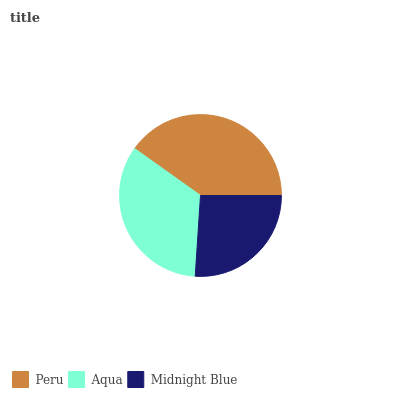Is Midnight Blue the minimum?
Answer yes or no. Yes. Is Peru the maximum?
Answer yes or no. Yes. Is Aqua the minimum?
Answer yes or no. No. Is Aqua the maximum?
Answer yes or no. No. Is Peru greater than Aqua?
Answer yes or no. Yes. Is Aqua less than Peru?
Answer yes or no. Yes. Is Aqua greater than Peru?
Answer yes or no. No. Is Peru less than Aqua?
Answer yes or no. No. Is Aqua the high median?
Answer yes or no. Yes. Is Aqua the low median?
Answer yes or no. Yes. Is Peru the high median?
Answer yes or no. No. Is Peru the low median?
Answer yes or no. No. 